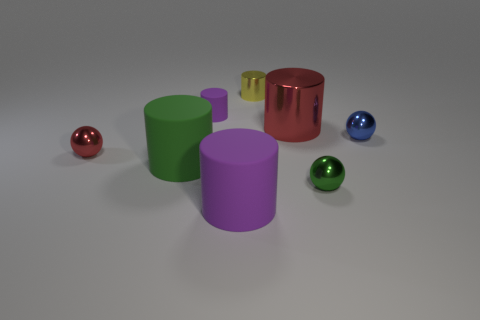What is the shape of the object that is the same color as the small matte cylinder?
Offer a very short reply. Cylinder. What size is the sphere that is the same color as the big metallic thing?
Your answer should be compact. Small. What is the color of the tiny shiny thing on the left side of the tiny cylinder that is left of the large purple cylinder?
Your answer should be very brief. Red. How many objects are tiny red shiny balls or rubber cylinders behind the red metallic sphere?
Your answer should be compact. 2. Are there any metallic spheres of the same color as the large metal object?
Keep it short and to the point. Yes. What number of gray things are either tiny metal cylinders or shiny spheres?
Offer a terse response. 0. How many other objects are there of the same size as the blue metallic sphere?
Give a very brief answer. 4. What number of big things are either purple cylinders or red metallic objects?
Offer a terse response. 2. There is a green shiny sphere; is its size the same as the red object in front of the large metal object?
Your answer should be compact. Yes. What number of other objects are there of the same shape as the tiny purple thing?
Your answer should be compact. 4. 